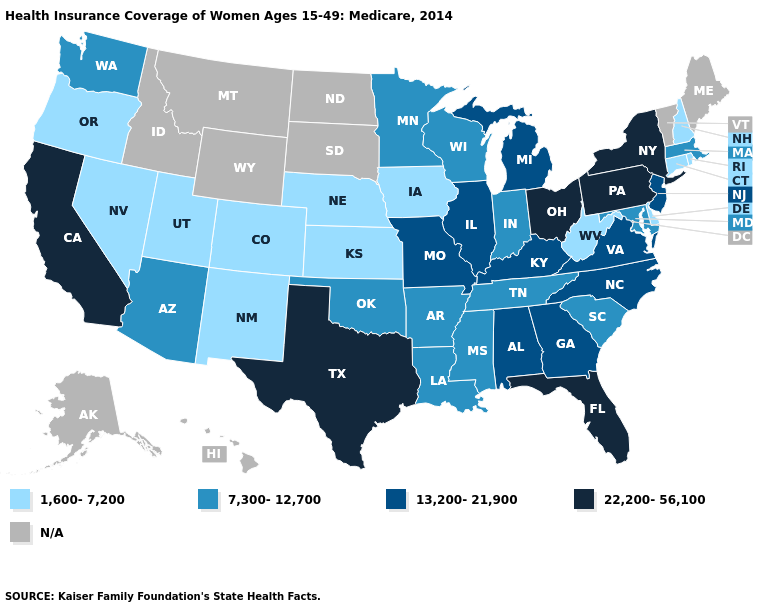Name the states that have a value in the range 22,200-56,100?
Give a very brief answer. California, Florida, New York, Ohio, Pennsylvania, Texas. Does the map have missing data?
Keep it brief. Yes. Among the states that border Mississippi , does Arkansas have the highest value?
Concise answer only. No. Among the states that border Kansas , does Colorado have the lowest value?
Be succinct. Yes. Name the states that have a value in the range 7,300-12,700?
Keep it brief. Arizona, Arkansas, Indiana, Louisiana, Maryland, Massachusetts, Minnesota, Mississippi, Oklahoma, South Carolina, Tennessee, Washington, Wisconsin. Name the states that have a value in the range 22,200-56,100?
Give a very brief answer. California, Florida, New York, Ohio, Pennsylvania, Texas. Name the states that have a value in the range N/A?
Give a very brief answer. Alaska, Hawaii, Idaho, Maine, Montana, North Dakota, South Dakota, Vermont, Wyoming. Among the states that border Nebraska , which have the lowest value?
Concise answer only. Colorado, Iowa, Kansas. Name the states that have a value in the range 7,300-12,700?
Short answer required. Arizona, Arkansas, Indiana, Louisiana, Maryland, Massachusetts, Minnesota, Mississippi, Oklahoma, South Carolina, Tennessee, Washington, Wisconsin. How many symbols are there in the legend?
Keep it brief. 5. Name the states that have a value in the range 13,200-21,900?
Short answer required. Alabama, Georgia, Illinois, Kentucky, Michigan, Missouri, New Jersey, North Carolina, Virginia. What is the value of North Carolina?
Short answer required. 13,200-21,900. Among the states that border Kansas , which have the highest value?
Write a very short answer. Missouri. Does New York have the highest value in the USA?
Keep it brief. Yes. Does Texas have the highest value in the USA?
Quick response, please. Yes. 